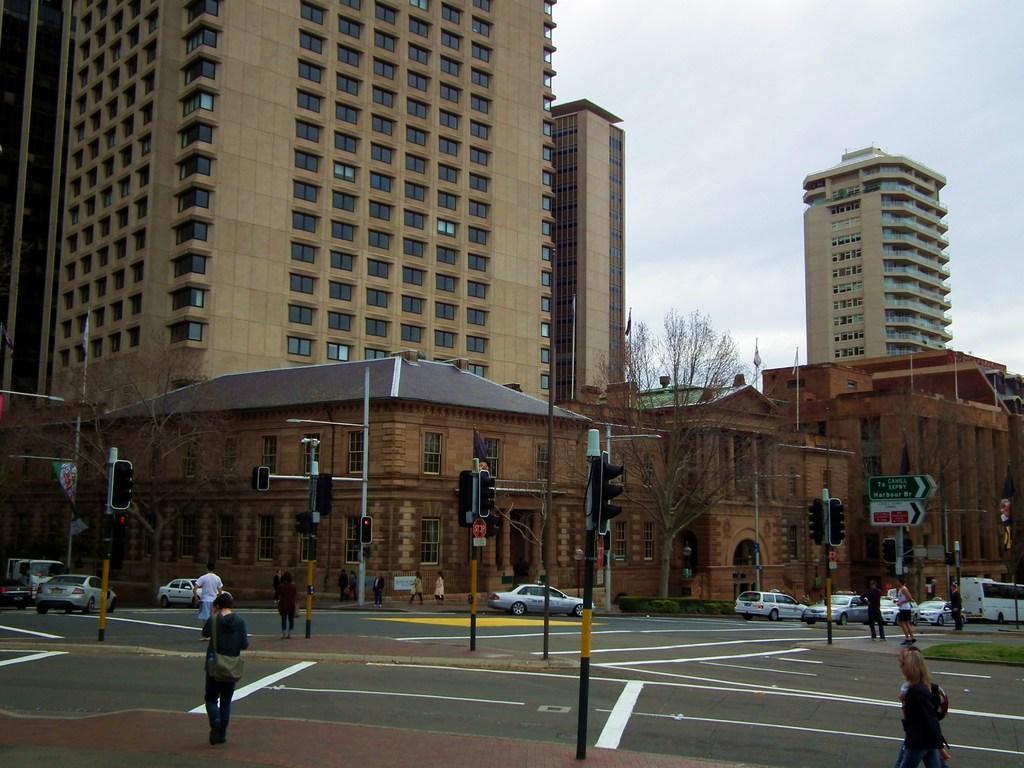Could you give a brief overview of what you see in this image? In the foreground I can see a crowd, traffic poles, fleets of cars and vehicles on the road. In the background I can see buildings, trees and windows. In the top right I can see the sky. This image is taken during a day. 